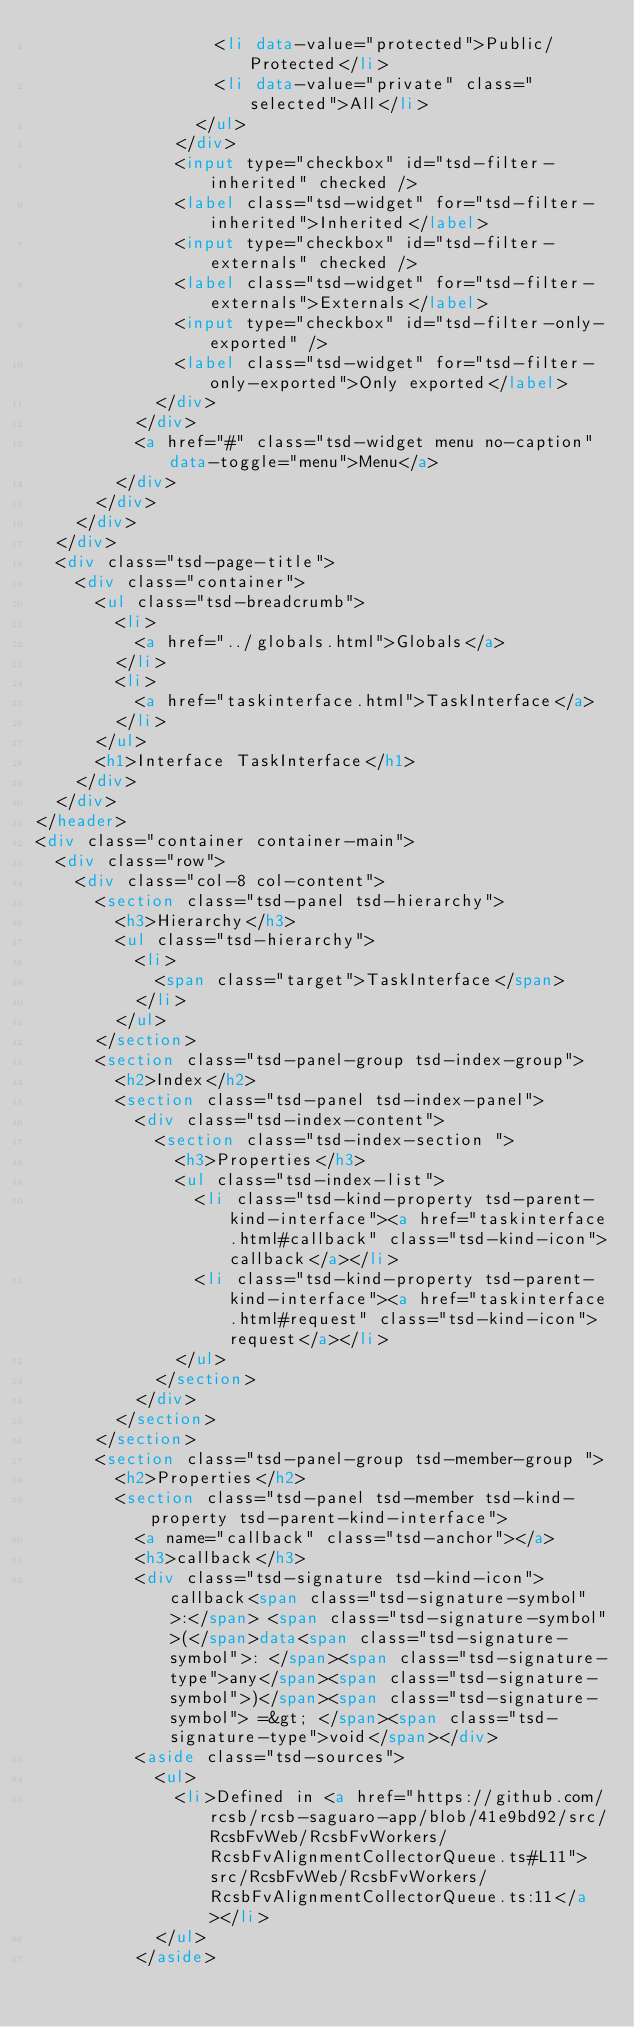Convert code to text. <code><loc_0><loc_0><loc_500><loc_500><_HTML_>									<li data-value="protected">Public/Protected</li>
									<li data-value="private" class="selected">All</li>
								</ul>
							</div>
							<input type="checkbox" id="tsd-filter-inherited" checked />
							<label class="tsd-widget" for="tsd-filter-inherited">Inherited</label>
							<input type="checkbox" id="tsd-filter-externals" checked />
							<label class="tsd-widget" for="tsd-filter-externals">Externals</label>
							<input type="checkbox" id="tsd-filter-only-exported" />
							<label class="tsd-widget" for="tsd-filter-only-exported">Only exported</label>
						</div>
					</div>
					<a href="#" class="tsd-widget menu no-caption" data-toggle="menu">Menu</a>
				</div>
			</div>
		</div>
	</div>
	<div class="tsd-page-title">
		<div class="container">
			<ul class="tsd-breadcrumb">
				<li>
					<a href="../globals.html">Globals</a>
				</li>
				<li>
					<a href="taskinterface.html">TaskInterface</a>
				</li>
			</ul>
			<h1>Interface TaskInterface</h1>
		</div>
	</div>
</header>
<div class="container container-main">
	<div class="row">
		<div class="col-8 col-content">
			<section class="tsd-panel tsd-hierarchy">
				<h3>Hierarchy</h3>
				<ul class="tsd-hierarchy">
					<li>
						<span class="target">TaskInterface</span>
					</li>
				</ul>
			</section>
			<section class="tsd-panel-group tsd-index-group">
				<h2>Index</h2>
				<section class="tsd-panel tsd-index-panel">
					<div class="tsd-index-content">
						<section class="tsd-index-section ">
							<h3>Properties</h3>
							<ul class="tsd-index-list">
								<li class="tsd-kind-property tsd-parent-kind-interface"><a href="taskinterface.html#callback" class="tsd-kind-icon">callback</a></li>
								<li class="tsd-kind-property tsd-parent-kind-interface"><a href="taskinterface.html#request" class="tsd-kind-icon">request</a></li>
							</ul>
						</section>
					</div>
				</section>
			</section>
			<section class="tsd-panel-group tsd-member-group ">
				<h2>Properties</h2>
				<section class="tsd-panel tsd-member tsd-kind-property tsd-parent-kind-interface">
					<a name="callback" class="tsd-anchor"></a>
					<h3>callback</h3>
					<div class="tsd-signature tsd-kind-icon">callback<span class="tsd-signature-symbol">:</span> <span class="tsd-signature-symbol">(</span>data<span class="tsd-signature-symbol">: </span><span class="tsd-signature-type">any</span><span class="tsd-signature-symbol">)</span><span class="tsd-signature-symbol"> =&gt; </span><span class="tsd-signature-type">void</span></div>
					<aside class="tsd-sources">
						<ul>
							<li>Defined in <a href="https://github.com/rcsb/rcsb-saguaro-app/blob/41e9bd92/src/RcsbFvWeb/RcsbFvWorkers/RcsbFvAlignmentCollectorQueue.ts#L11">src/RcsbFvWeb/RcsbFvWorkers/RcsbFvAlignmentCollectorQueue.ts:11</a></li>
						</ul>
					</aside></code> 